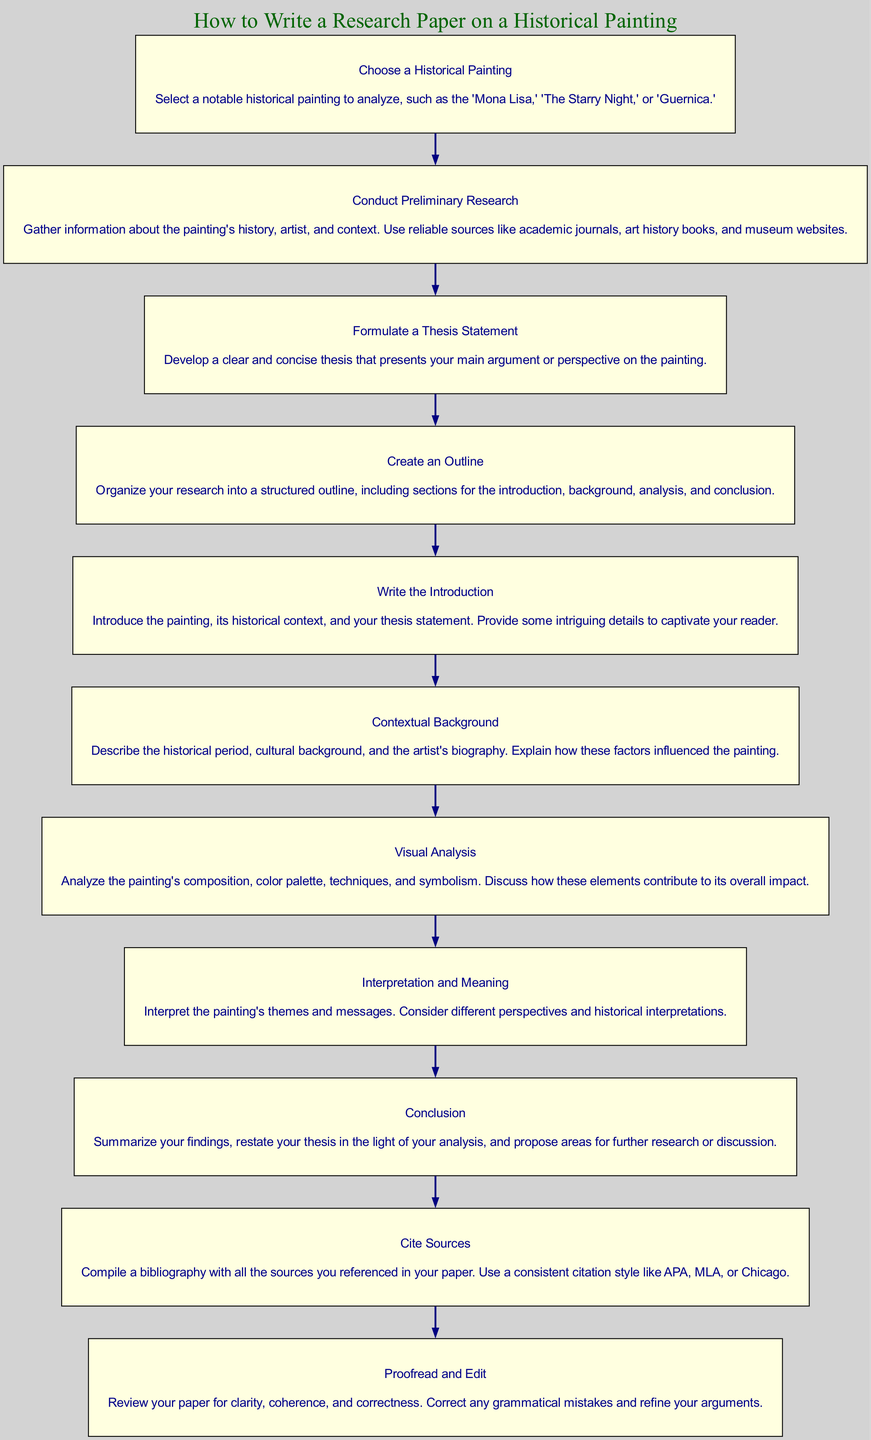What is the first step in writing a research paper on a historical painting? The first step, as indicated in the diagram, is to "Choose a Historical Painting." This is the initial action that sets the stage for the entire research process.
Answer: Choose a Historical Painting How many main steps are outlined in the diagram? By looking at the flow chart, we can count a total of 10 nodes, each representing a different step in the process of writing the paper. These nodes signify the sequence of actions to be taken.
Answer: 10 What follows after "Conduct Preliminary Research"? According to the diagram, the step that immediately follows "Conduct Preliminary Research" is "Formulate a Thesis Statement." This highlights the progression from gathering data to articulating a main argument.
Answer: Formulate a Thesis Statement What type of analysis is included in the diagram? The diagram specifies a step called "Visual Analysis," which focuses on analyzing the painting's composition, color palette, techniques, and symbolism, all crucial for understanding the artwork's impact.
Answer: Visual Analysis What is the last step in the flow chart? Looking at the diagram, the final step detailed is "Proofread and Edit." This step emphasizes the importance of reviewing the paper before final submission.
Answer: Proofread and Edit Which step involves summarizing findings? The step where summarizing findings occurs is "Conclusion." In this part, the author is expected to restate the thesis based on the analysis conducted throughout the paper.
Answer: Conclusion What must be done before writing the introduction? Before writing the introduction, it is essential to complete "Create an Outline," as indicated in the flow chart. This structured plan provides a roadmap for writing the paper effectively.
Answer: Create an Outline What does the step "Cite Sources" entail? The "Cite Sources" step involves compiling a bibliography of all references used throughout the research paper, ensuring proper credit is attributed according to citation styles.
Answer: Compile a bibliography Which step requires the interpretation of themes? The step that entails the interpretation of themes and messages within the painting is "Interpretation and Meaning." This allows for an in-depth exploration of the painting's significance.
Answer: Interpretation and Meaning How is the visual analysis characterized in the diagram? The diagram characterizes the visual analysis as focusing on aspects like composition, color palette, techniques, and symbolism—all critical to understanding the artwork's overall impact.
Answer: Composition, color palette, techniques, symbolism 